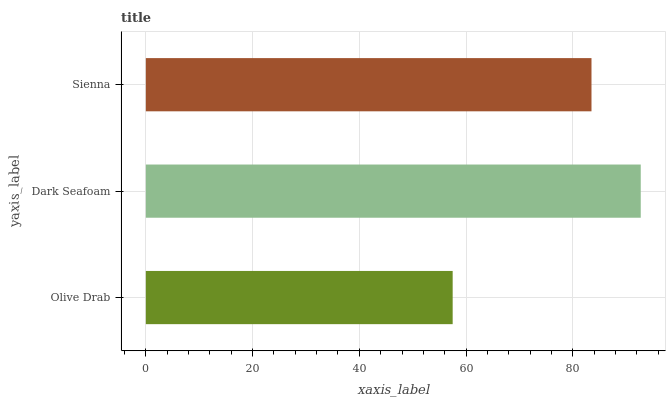Is Olive Drab the minimum?
Answer yes or no. Yes. Is Dark Seafoam the maximum?
Answer yes or no. Yes. Is Sienna the minimum?
Answer yes or no. No. Is Sienna the maximum?
Answer yes or no. No. Is Dark Seafoam greater than Sienna?
Answer yes or no. Yes. Is Sienna less than Dark Seafoam?
Answer yes or no. Yes. Is Sienna greater than Dark Seafoam?
Answer yes or no. No. Is Dark Seafoam less than Sienna?
Answer yes or no. No. Is Sienna the high median?
Answer yes or no. Yes. Is Sienna the low median?
Answer yes or no. Yes. Is Olive Drab the high median?
Answer yes or no. No. Is Olive Drab the low median?
Answer yes or no. No. 